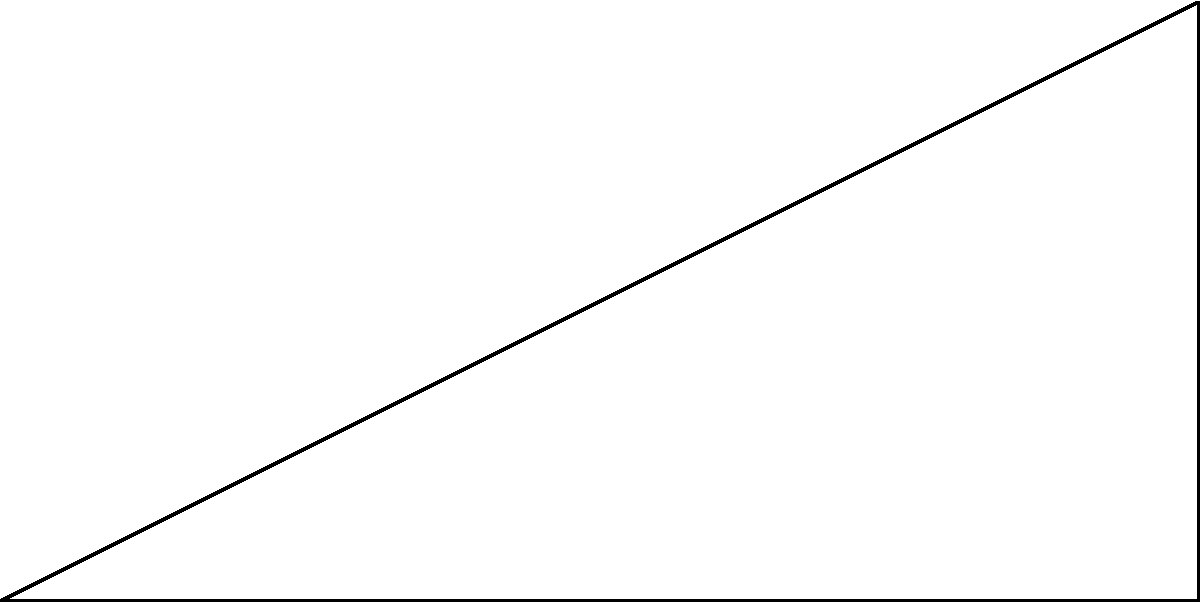In a forensic ballistics scenario, a bullet is fired from ground level (point O) and hits a building 30 meters away at a height of 15 meters (point B). What is the angle of trajectory ($\theta$) of the bullet, assuming it follows a straight path? To solve this problem, we'll use trigonometry, specifically the tangent function. Let's approach this step-by-step:

1) We have a right-angled triangle OAB, where:
   - OA is the horizontal distance (30 m)
   - AB is the vertical height (15 m)
   - Angle $\theta$ is what we need to find

2) In a right-angled triangle, $\tan(\theta) = \frac{\text{opposite}}{\text{adjacent}}$

3) In this case:
   - The opposite side is AB (15 m)
   - The adjacent side is OA (30 m)

4) So we can write:
   $\tan(\theta) = \frac{15}{30} = \frac{1}{2} = 0.5$

5) To find $\theta$, we need to use the inverse tangent function (arctan or $\tan^{-1}$):
   $\theta = \tan^{-1}(0.5)$

6) Using a calculator or trigonometric tables:
   $\theta \approx 26.57^\circ$

Therefore, the angle of trajectory of the bullet is approximately 26.57 degrees.
Answer: $26.57^\circ$ 